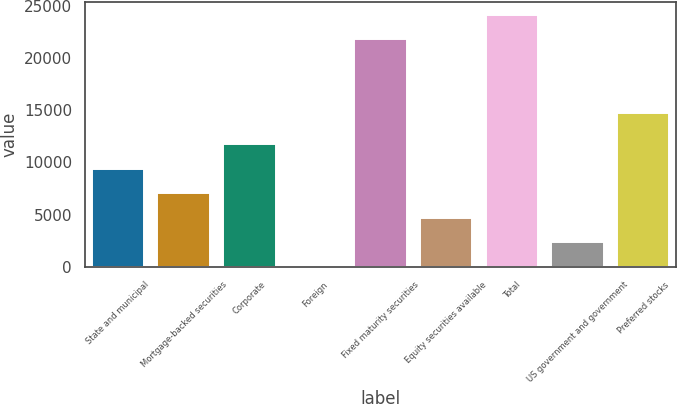<chart> <loc_0><loc_0><loc_500><loc_500><bar_chart><fcel>State and municipal<fcel>Mortgage-backed securities<fcel>Corporate<fcel>Foreign<fcel>Fixed maturity securities<fcel>Equity securities available<fcel>Total<fcel>US government and government<fcel>Preferred stocks<nl><fcel>9386<fcel>7046.5<fcel>11725.5<fcel>28<fcel>21772<fcel>4707<fcel>24111.5<fcel>2367.5<fcel>14740<nl></chart> 